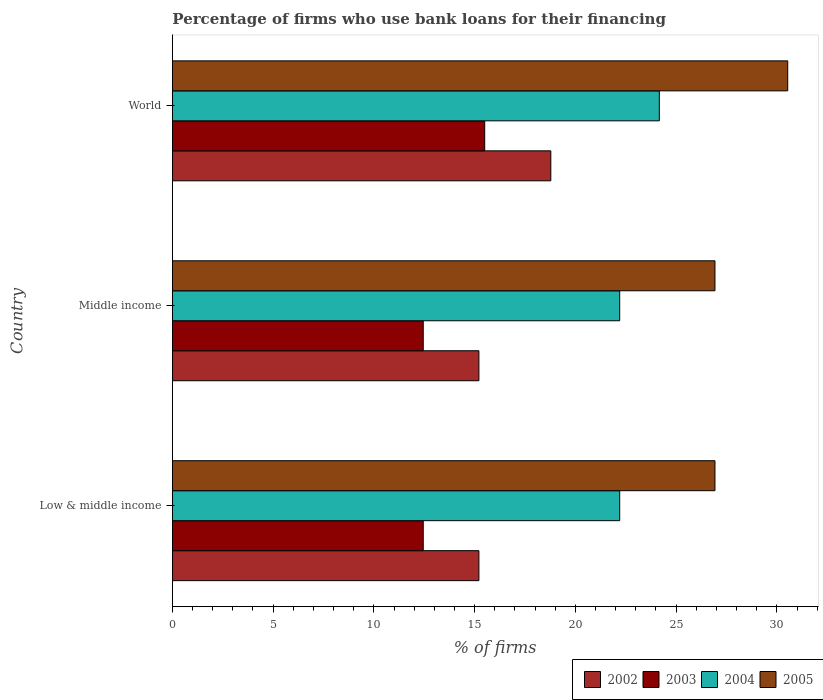How many different coloured bars are there?
Provide a short and direct response. 4. How many groups of bars are there?
Keep it short and to the point. 3. Are the number of bars per tick equal to the number of legend labels?
Keep it short and to the point. Yes. Are the number of bars on each tick of the Y-axis equal?
Provide a succinct answer. Yes. How many bars are there on the 3rd tick from the top?
Provide a succinct answer. 4. What is the percentage of firms who use bank loans for their financing in 2005 in Low & middle income?
Keep it short and to the point. 26.93. Across all countries, what is the maximum percentage of firms who use bank loans for their financing in 2004?
Keep it short and to the point. 24.17. Across all countries, what is the minimum percentage of firms who use bank loans for their financing in 2002?
Your response must be concise. 15.21. What is the total percentage of firms who use bank loans for their financing in 2003 in the graph?
Provide a succinct answer. 40.4. What is the difference between the percentage of firms who use bank loans for their financing in 2003 in Middle income and the percentage of firms who use bank loans for their financing in 2004 in Low & middle income?
Provide a succinct answer. -9.75. What is the average percentage of firms who use bank loans for their financing in 2003 per country?
Your answer should be compact. 13.47. What is the difference between the percentage of firms who use bank loans for their financing in 2005 and percentage of firms who use bank loans for their financing in 2003 in Low & middle income?
Your answer should be compact. 14.48. In how many countries, is the percentage of firms who use bank loans for their financing in 2004 greater than 31 %?
Keep it short and to the point. 0. Is the percentage of firms who use bank loans for their financing in 2005 in Low & middle income less than that in Middle income?
Ensure brevity in your answer.  No. Is the difference between the percentage of firms who use bank loans for their financing in 2005 in Low & middle income and World greater than the difference between the percentage of firms who use bank loans for their financing in 2003 in Low & middle income and World?
Keep it short and to the point. No. What is the difference between the highest and the second highest percentage of firms who use bank loans for their financing in 2003?
Keep it short and to the point. 3.05. What is the difference between the highest and the lowest percentage of firms who use bank loans for their financing in 2005?
Offer a very short reply. 3.61. In how many countries, is the percentage of firms who use bank loans for their financing in 2005 greater than the average percentage of firms who use bank loans for their financing in 2005 taken over all countries?
Give a very brief answer. 1. Is the sum of the percentage of firms who use bank loans for their financing in 2002 in Middle income and World greater than the maximum percentage of firms who use bank loans for their financing in 2003 across all countries?
Ensure brevity in your answer.  Yes. What does the 4th bar from the top in Low & middle income represents?
Keep it short and to the point. 2002. What does the 4th bar from the bottom in World represents?
Your response must be concise. 2005. Is it the case that in every country, the sum of the percentage of firms who use bank loans for their financing in 2004 and percentage of firms who use bank loans for their financing in 2005 is greater than the percentage of firms who use bank loans for their financing in 2002?
Provide a short and direct response. Yes. How many countries are there in the graph?
Offer a terse response. 3. Are the values on the major ticks of X-axis written in scientific E-notation?
Offer a very short reply. No. Does the graph contain any zero values?
Give a very brief answer. No. Does the graph contain grids?
Provide a succinct answer. No. Where does the legend appear in the graph?
Give a very brief answer. Bottom right. What is the title of the graph?
Provide a succinct answer. Percentage of firms who use bank loans for their financing. Does "1979" appear as one of the legend labels in the graph?
Offer a terse response. No. What is the label or title of the X-axis?
Give a very brief answer. % of firms. What is the % of firms of 2002 in Low & middle income?
Your response must be concise. 15.21. What is the % of firms in 2003 in Low & middle income?
Ensure brevity in your answer.  12.45. What is the % of firms in 2005 in Low & middle income?
Your answer should be very brief. 26.93. What is the % of firms in 2002 in Middle income?
Offer a very short reply. 15.21. What is the % of firms of 2003 in Middle income?
Make the answer very short. 12.45. What is the % of firms of 2004 in Middle income?
Provide a succinct answer. 22.2. What is the % of firms in 2005 in Middle income?
Your answer should be compact. 26.93. What is the % of firms in 2002 in World?
Make the answer very short. 18.78. What is the % of firms of 2003 in World?
Give a very brief answer. 15.5. What is the % of firms of 2004 in World?
Provide a succinct answer. 24.17. What is the % of firms of 2005 in World?
Make the answer very short. 30.54. Across all countries, what is the maximum % of firms in 2002?
Give a very brief answer. 18.78. Across all countries, what is the maximum % of firms in 2004?
Keep it short and to the point. 24.17. Across all countries, what is the maximum % of firms in 2005?
Keep it short and to the point. 30.54. Across all countries, what is the minimum % of firms of 2002?
Your answer should be very brief. 15.21. Across all countries, what is the minimum % of firms in 2003?
Give a very brief answer. 12.45. Across all countries, what is the minimum % of firms of 2005?
Your answer should be compact. 26.93. What is the total % of firms in 2002 in the graph?
Provide a succinct answer. 49.21. What is the total % of firms in 2003 in the graph?
Keep it short and to the point. 40.4. What is the total % of firms in 2004 in the graph?
Offer a very short reply. 68.57. What is the total % of firms of 2005 in the graph?
Your response must be concise. 84.39. What is the difference between the % of firms of 2004 in Low & middle income and that in Middle income?
Your answer should be very brief. 0. What is the difference between the % of firms in 2005 in Low & middle income and that in Middle income?
Your answer should be compact. 0. What is the difference between the % of firms of 2002 in Low & middle income and that in World?
Make the answer very short. -3.57. What is the difference between the % of firms in 2003 in Low & middle income and that in World?
Make the answer very short. -3.05. What is the difference between the % of firms in 2004 in Low & middle income and that in World?
Offer a terse response. -1.97. What is the difference between the % of firms in 2005 in Low & middle income and that in World?
Offer a terse response. -3.61. What is the difference between the % of firms of 2002 in Middle income and that in World?
Give a very brief answer. -3.57. What is the difference between the % of firms in 2003 in Middle income and that in World?
Your answer should be compact. -3.05. What is the difference between the % of firms in 2004 in Middle income and that in World?
Your answer should be very brief. -1.97. What is the difference between the % of firms of 2005 in Middle income and that in World?
Keep it short and to the point. -3.61. What is the difference between the % of firms of 2002 in Low & middle income and the % of firms of 2003 in Middle income?
Keep it short and to the point. 2.76. What is the difference between the % of firms in 2002 in Low & middle income and the % of firms in 2004 in Middle income?
Make the answer very short. -6.99. What is the difference between the % of firms of 2002 in Low & middle income and the % of firms of 2005 in Middle income?
Your response must be concise. -11.72. What is the difference between the % of firms of 2003 in Low & middle income and the % of firms of 2004 in Middle income?
Make the answer very short. -9.75. What is the difference between the % of firms of 2003 in Low & middle income and the % of firms of 2005 in Middle income?
Ensure brevity in your answer.  -14.48. What is the difference between the % of firms in 2004 in Low & middle income and the % of firms in 2005 in Middle income?
Give a very brief answer. -4.73. What is the difference between the % of firms of 2002 in Low & middle income and the % of firms of 2003 in World?
Give a very brief answer. -0.29. What is the difference between the % of firms of 2002 in Low & middle income and the % of firms of 2004 in World?
Offer a terse response. -8.95. What is the difference between the % of firms of 2002 in Low & middle income and the % of firms of 2005 in World?
Make the answer very short. -15.33. What is the difference between the % of firms of 2003 in Low & middle income and the % of firms of 2004 in World?
Give a very brief answer. -11.72. What is the difference between the % of firms of 2003 in Low & middle income and the % of firms of 2005 in World?
Ensure brevity in your answer.  -18.09. What is the difference between the % of firms of 2004 in Low & middle income and the % of firms of 2005 in World?
Offer a very short reply. -8.34. What is the difference between the % of firms of 2002 in Middle income and the % of firms of 2003 in World?
Make the answer very short. -0.29. What is the difference between the % of firms in 2002 in Middle income and the % of firms in 2004 in World?
Make the answer very short. -8.95. What is the difference between the % of firms in 2002 in Middle income and the % of firms in 2005 in World?
Provide a short and direct response. -15.33. What is the difference between the % of firms of 2003 in Middle income and the % of firms of 2004 in World?
Keep it short and to the point. -11.72. What is the difference between the % of firms in 2003 in Middle income and the % of firms in 2005 in World?
Your answer should be very brief. -18.09. What is the difference between the % of firms of 2004 in Middle income and the % of firms of 2005 in World?
Give a very brief answer. -8.34. What is the average % of firms of 2002 per country?
Your answer should be very brief. 16.4. What is the average % of firms of 2003 per country?
Provide a short and direct response. 13.47. What is the average % of firms in 2004 per country?
Your answer should be compact. 22.86. What is the average % of firms in 2005 per country?
Your answer should be very brief. 28.13. What is the difference between the % of firms in 2002 and % of firms in 2003 in Low & middle income?
Give a very brief answer. 2.76. What is the difference between the % of firms of 2002 and % of firms of 2004 in Low & middle income?
Your answer should be very brief. -6.99. What is the difference between the % of firms of 2002 and % of firms of 2005 in Low & middle income?
Provide a short and direct response. -11.72. What is the difference between the % of firms in 2003 and % of firms in 2004 in Low & middle income?
Your answer should be compact. -9.75. What is the difference between the % of firms in 2003 and % of firms in 2005 in Low & middle income?
Your answer should be very brief. -14.48. What is the difference between the % of firms of 2004 and % of firms of 2005 in Low & middle income?
Your response must be concise. -4.73. What is the difference between the % of firms in 2002 and % of firms in 2003 in Middle income?
Offer a terse response. 2.76. What is the difference between the % of firms of 2002 and % of firms of 2004 in Middle income?
Provide a short and direct response. -6.99. What is the difference between the % of firms of 2002 and % of firms of 2005 in Middle income?
Ensure brevity in your answer.  -11.72. What is the difference between the % of firms of 2003 and % of firms of 2004 in Middle income?
Make the answer very short. -9.75. What is the difference between the % of firms of 2003 and % of firms of 2005 in Middle income?
Provide a succinct answer. -14.48. What is the difference between the % of firms in 2004 and % of firms in 2005 in Middle income?
Your answer should be very brief. -4.73. What is the difference between the % of firms in 2002 and % of firms in 2003 in World?
Give a very brief answer. 3.28. What is the difference between the % of firms in 2002 and % of firms in 2004 in World?
Your answer should be very brief. -5.39. What is the difference between the % of firms of 2002 and % of firms of 2005 in World?
Offer a terse response. -11.76. What is the difference between the % of firms in 2003 and % of firms in 2004 in World?
Give a very brief answer. -8.67. What is the difference between the % of firms in 2003 and % of firms in 2005 in World?
Your answer should be compact. -15.04. What is the difference between the % of firms of 2004 and % of firms of 2005 in World?
Your answer should be compact. -6.37. What is the ratio of the % of firms of 2002 in Low & middle income to that in Middle income?
Keep it short and to the point. 1. What is the ratio of the % of firms of 2004 in Low & middle income to that in Middle income?
Offer a terse response. 1. What is the ratio of the % of firms in 2002 in Low & middle income to that in World?
Your answer should be very brief. 0.81. What is the ratio of the % of firms in 2003 in Low & middle income to that in World?
Give a very brief answer. 0.8. What is the ratio of the % of firms in 2004 in Low & middle income to that in World?
Your response must be concise. 0.92. What is the ratio of the % of firms in 2005 in Low & middle income to that in World?
Provide a short and direct response. 0.88. What is the ratio of the % of firms of 2002 in Middle income to that in World?
Your answer should be compact. 0.81. What is the ratio of the % of firms in 2003 in Middle income to that in World?
Offer a very short reply. 0.8. What is the ratio of the % of firms of 2004 in Middle income to that in World?
Provide a succinct answer. 0.92. What is the ratio of the % of firms of 2005 in Middle income to that in World?
Your answer should be compact. 0.88. What is the difference between the highest and the second highest % of firms in 2002?
Your answer should be very brief. 3.57. What is the difference between the highest and the second highest % of firms of 2003?
Ensure brevity in your answer.  3.05. What is the difference between the highest and the second highest % of firms in 2004?
Keep it short and to the point. 1.97. What is the difference between the highest and the second highest % of firms in 2005?
Keep it short and to the point. 3.61. What is the difference between the highest and the lowest % of firms in 2002?
Keep it short and to the point. 3.57. What is the difference between the highest and the lowest % of firms in 2003?
Your response must be concise. 3.05. What is the difference between the highest and the lowest % of firms in 2004?
Your answer should be compact. 1.97. What is the difference between the highest and the lowest % of firms in 2005?
Make the answer very short. 3.61. 